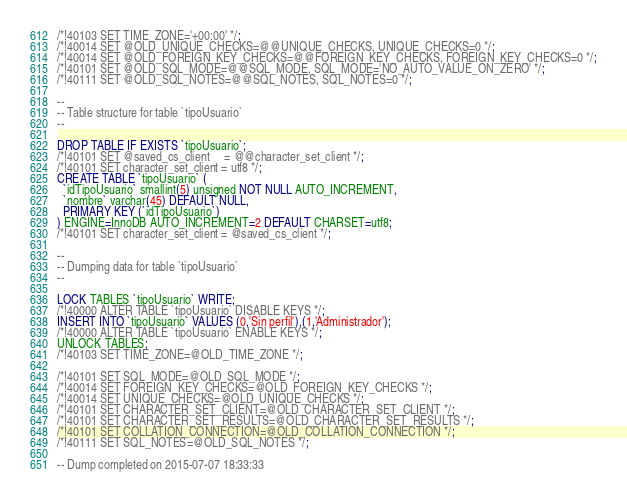<code> <loc_0><loc_0><loc_500><loc_500><_SQL_>/*!40103 SET TIME_ZONE='+00:00' */;
/*!40014 SET @OLD_UNIQUE_CHECKS=@@UNIQUE_CHECKS, UNIQUE_CHECKS=0 */;
/*!40014 SET @OLD_FOREIGN_KEY_CHECKS=@@FOREIGN_KEY_CHECKS, FOREIGN_KEY_CHECKS=0 */;
/*!40101 SET @OLD_SQL_MODE=@@SQL_MODE, SQL_MODE='NO_AUTO_VALUE_ON_ZERO' */;
/*!40111 SET @OLD_SQL_NOTES=@@SQL_NOTES, SQL_NOTES=0 */;

--
-- Table structure for table `tipoUsuario`
--

DROP TABLE IF EXISTS `tipoUsuario`;
/*!40101 SET @saved_cs_client     = @@character_set_client */;
/*!40101 SET character_set_client = utf8 */;
CREATE TABLE `tipoUsuario` (
  `idTipoUsuario` smallint(5) unsigned NOT NULL AUTO_INCREMENT,
  `nombre` varchar(45) DEFAULT NULL,
  PRIMARY KEY (`idTipoUsuario`)
) ENGINE=InnoDB AUTO_INCREMENT=2 DEFAULT CHARSET=utf8;
/*!40101 SET character_set_client = @saved_cs_client */;

--
-- Dumping data for table `tipoUsuario`
--

LOCK TABLES `tipoUsuario` WRITE;
/*!40000 ALTER TABLE `tipoUsuario` DISABLE KEYS */;
INSERT INTO `tipoUsuario` VALUES (0,'Sin perfil'),(1,'Administrador');
/*!40000 ALTER TABLE `tipoUsuario` ENABLE KEYS */;
UNLOCK TABLES;
/*!40103 SET TIME_ZONE=@OLD_TIME_ZONE */;

/*!40101 SET SQL_MODE=@OLD_SQL_MODE */;
/*!40014 SET FOREIGN_KEY_CHECKS=@OLD_FOREIGN_KEY_CHECKS */;
/*!40014 SET UNIQUE_CHECKS=@OLD_UNIQUE_CHECKS */;
/*!40101 SET CHARACTER_SET_CLIENT=@OLD_CHARACTER_SET_CLIENT */;
/*!40101 SET CHARACTER_SET_RESULTS=@OLD_CHARACTER_SET_RESULTS */;
/*!40101 SET COLLATION_CONNECTION=@OLD_COLLATION_CONNECTION */;
/*!40111 SET SQL_NOTES=@OLD_SQL_NOTES */;

-- Dump completed on 2015-07-07 18:33:33
</code> 